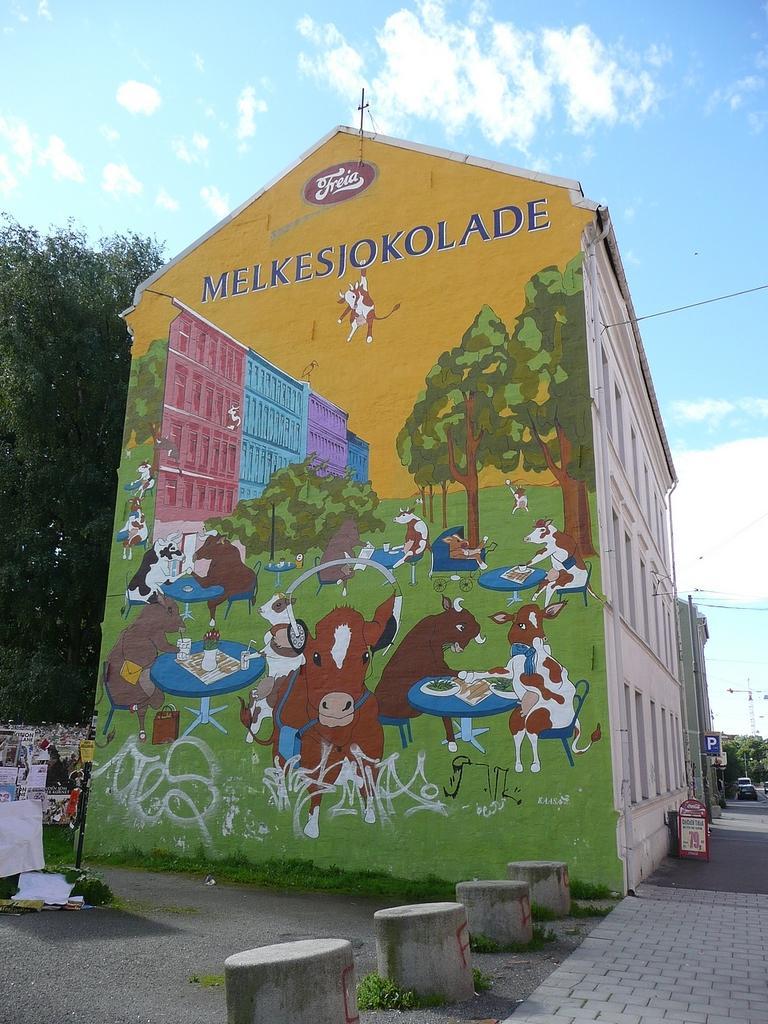Could you give a brief overview of what you see in this image? In the picture I can see the buildings on the side of the road. I can see the painting on the wall of the building. I can see the trees on the left side. I can see a vehicle on the road on the right side. There are clouds in the sky. 